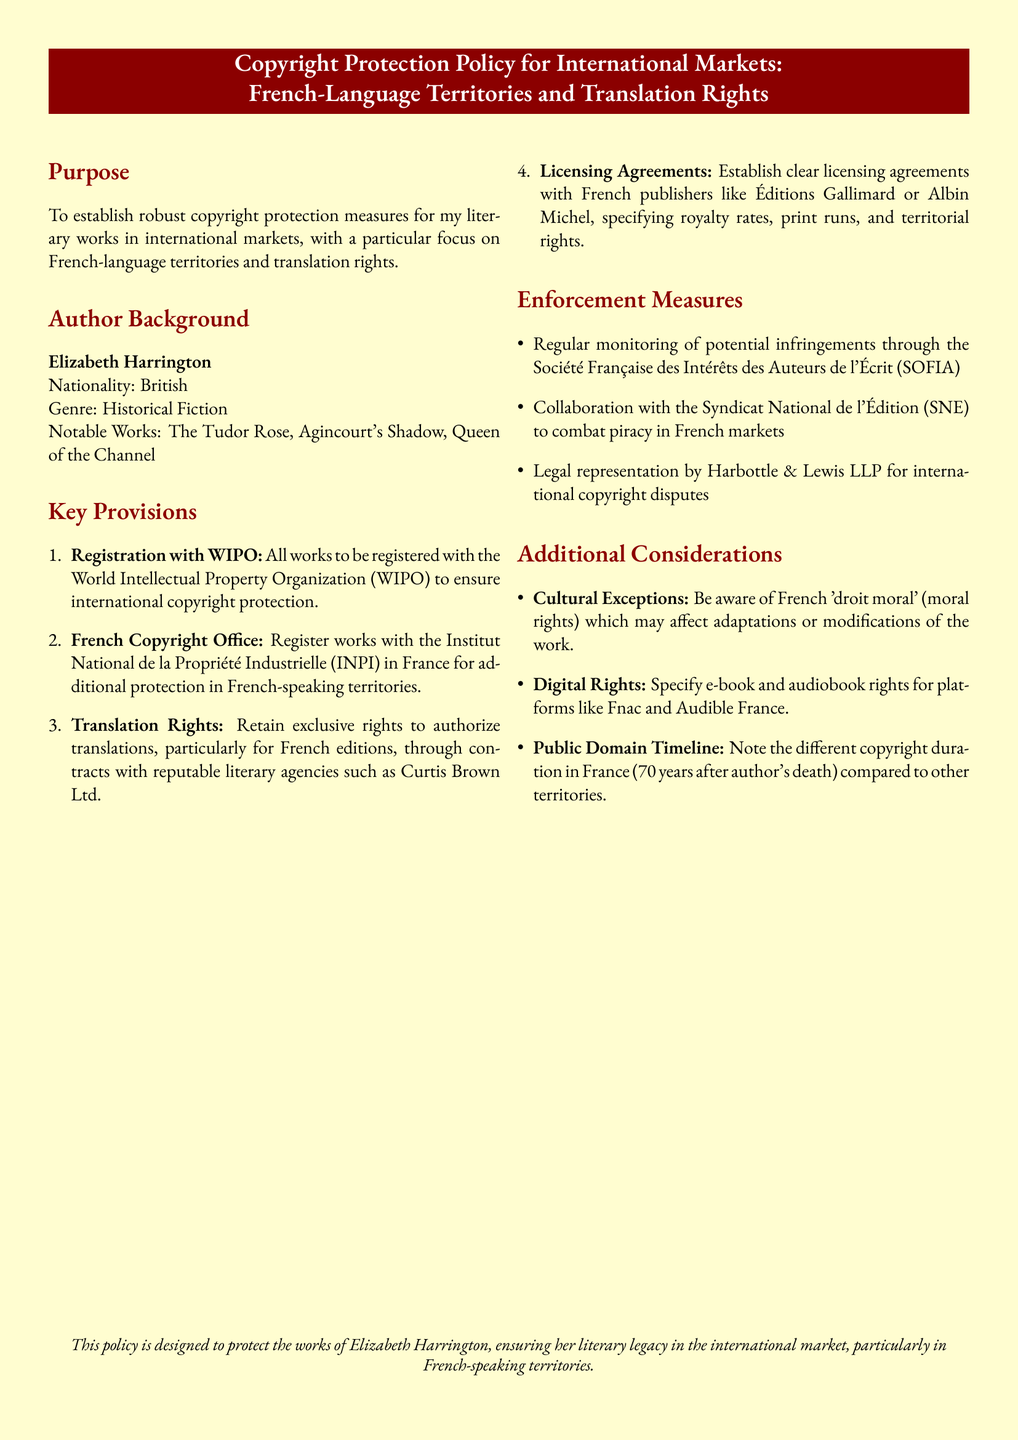What is the author’s name? The author’s name is clearly stated in the document, highlighting her identity.
Answer: Elizabeth Harrington Which office should works be registered with in France? The document specifies the French authority responsible for copyright registration.
Answer: Institut National de la Propriété Industrielle What genre does Elizabeth Harrington write? The genre is mentioned in the author background section.
Answer: Historical Fiction What is the primary focus of this copyright protection policy? The purpose section outlines the main focus of the policy document.
Answer: French-language territories and translation rights Who is the legal representative for international copyright disputes? The enforcement measures list the name of the law firm providing legal representation.
Answer: Harbottle & Lewis LLP What is the copyright duration in France compared to other territories? The document mentions the specific duration in relation to the territory's copyright laws.
Answer: 70 years after author's death Which literary agency is mentioned for translation rights? The key provisions section lists a notable agency for translation rights.
Answer: Curtis Brown Ltd What is the name of the organization that monitors potential infringements? The enforcement measures detail the organization responsible for monitoring.
Answer: Société Française des Intérêts des Auteurs de l'Écrit What are two types of rights specified for digital formats? The additional considerations section refers to rights related to electronic versions of the literary works.
Answer: e-book and audiobook rights 